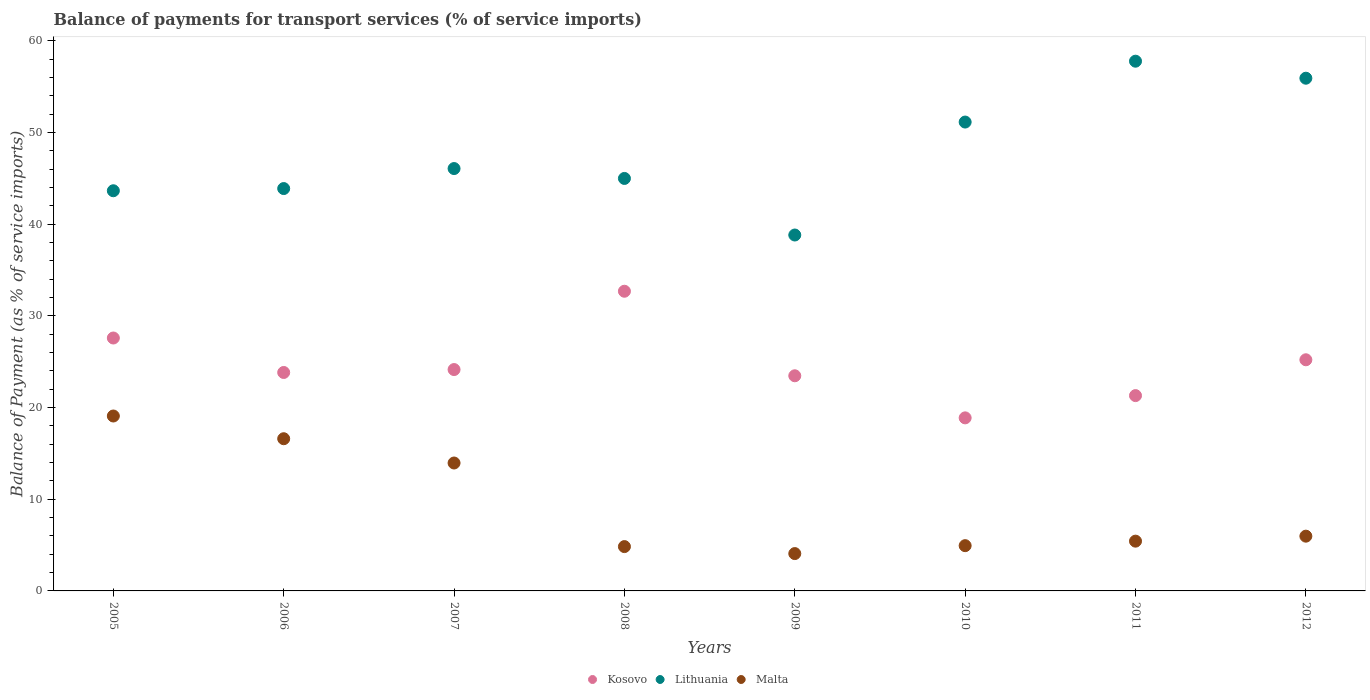What is the balance of payments for transport services in Lithuania in 2011?
Your answer should be compact. 57.79. Across all years, what is the maximum balance of payments for transport services in Kosovo?
Your answer should be very brief. 32.7. Across all years, what is the minimum balance of payments for transport services in Malta?
Give a very brief answer. 4.07. What is the total balance of payments for transport services in Lithuania in the graph?
Offer a very short reply. 382.36. What is the difference between the balance of payments for transport services in Malta in 2005 and that in 2006?
Give a very brief answer. 2.48. What is the difference between the balance of payments for transport services in Malta in 2009 and the balance of payments for transport services in Kosovo in 2007?
Keep it short and to the point. -20.08. What is the average balance of payments for transport services in Kosovo per year?
Your answer should be compact. 24.64. In the year 2010, what is the difference between the balance of payments for transport services in Malta and balance of payments for transport services in Kosovo?
Ensure brevity in your answer.  -13.94. What is the ratio of the balance of payments for transport services in Malta in 2006 to that in 2007?
Make the answer very short. 1.19. What is the difference between the highest and the second highest balance of payments for transport services in Kosovo?
Give a very brief answer. 5.1. What is the difference between the highest and the lowest balance of payments for transport services in Malta?
Offer a very short reply. 15.01. In how many years, is the balance of payments for transport services in Lithuania greater than the average balance of payments for transport services in Lithuania taken over all years?
Provide a succinct answer. 3. Is the sum of the balance of payments for transport services in Lithuania in 2006 and 2012 greater than the maximum balance of payments for transport services in Kosovo across all years?
Provide a succinct answer. Yes. Is the balance of payments for transport services in Lithuania strictly greater than the balance of payments for transport services in Malta over the years?
Give a very brief answer. Yes. What is the difference between two consecutive major ticks on the Y-axis?
Give a very brief answer. 10. Does the graph contain any zero values?
Make the answer very short. No. Does the graph contain grids?
Offer a very short reply. No. How many legend labels are there?
Your answer should be compact. 3. What is the title of the graph?
Offer a terse response. Balance of payments for transport services (% of service imports). What is the label or title of the X-axis?
Your response must be concise. Years. What is the label or title of the Y-axis?
Your answer should be compact. Balance of Payment (as % of service imports). What is the Balance of Payment (as % of service imports) of Kosovo in 2005?
Your answer should be compact. 27.59. What is the Balance of Payment (as % of service imports) in Lithuania in 2005?
Provide a short and direct response. 43.66. What is the Balance of Payment (as % of service imports) in Malta in 2005?
Offer a terse response. 19.08. What is the Balance of Payment (as % of service imports) in Kosovo in 2006?
Make the answer very short. 23.83. What is the Balance of Payment (as % of service imports) in Lithuania in 2006?
Provide a succinct answer. 43.9. What is the Balance of Payment (as % of service imports) of Malta in 2006?
Provide a succinct answer. 16.61. What is the Balance of Payment (as % of service imports) in Kosovo in 2007?
Your answer should be compact. 24.15. What is the Balance of Payment (as % of service imports) of Lithuania in 2007?
Your answer should be compact. 46.08. What is the Balance of Payment (as % of service imports) in Malta in 2007?
Ensure brevity in your answer.  13.96. What is the Balance of Payment (as % of service imports) in Kosovo in 2008?
Your answer should be compact. 32.7. What is the Balance of Payment (as % of service imports) of Lithuania in 2008?
Provide a succinct answer. 45. What is the Balance of Payment (as % of service imports) in Malta in 2008?
Give a very brief answer. 4.84. What is the Balance of Payment (as % of service imports) in Kosovo in 2009?
Make the answer very short. 23.47. What is the Balance of Payment (as % of service imports) in Lithuania in 2009?
Keep it short and to the point. 38.83. What is the Balance of Payment (as % of service imports) of Malta in 2009?
Offer a terse response. 4.07. What is the Balance of Payment (as % of service imports) of Kosovo in 2010?
Ensure brevity in your answer.  18.88. What is the Balance of Payment (as % of service imports) of Lithuania in 2010?
Your answer should be very brief. 51.15. What is the Balance of Payment (as % of service imports) of Malta in 2010?
Make the answer very short. 4.94. What is the Balance of Payment (as % of service imports) in Kosovo in 2011?
Provide a succinct answer. 21.31. What is the Balance of Payment (as % of service imports) of Lithuania in 2011?
Give a very brief answer. 57.79. What is the Balance of Payment (as % of service imports) in Malta in 2011?
Your answer should be compact. 5.43. What is the Balance of Payment (as % of service imports) of Kosovo in 2012?
Your answer should be very brief. 25.22. What is the Balance of Payment (as % of service imports) in Lithuania in 2012?
Your answer should be very brief. 55.94. What is the Balance of Payment (as % of service imports) in Malta in 2012?
Make the answer very short. 5.97. Across all years, what is the maximum Balance of Payment (as % of service imports) of Kosovo?
Provide a short and direct response. 32.7. Across all years, what is the maximum Balance of Payment (as % of service imports) in Lithuania?
Provide a short and direct response. 57.79. Across all years, what is the maximum Balance of Payment (as % of service imports) in Malta?
Provide a short and direct response. 19.08. Across all years, what is the minimum Balance of Payment (as % of service imports) of Kosovo?
Your answer should be very brief. 18.88. Across all years, what is the minimum Balance of Payment (as % of service imports) in Lithuania?
Provide a succinct answer. 38.83. Across all years, what is the minimum Balance of Payment (as % of service imports) in Malta?
Provide a short and direct response. 4.07. What is the total Balance of Payment (as % of service imports) of Kosovo in the graph?
Your answer should be compact. 197.16. What is the total Balance of Payment (as % of service imports) in Lithuania in the graph?
Provide a short and direct response. 382.36. What is the total Balance of Payment (as % of service imports) of Malta in the graph?
Make the answer very short. 74.9. What is the difference between the Balance of Payment (as % of service imports) in Kosovo in 2005 and that in 2006?
Offer a terse response. 3.76. What is the difference between the Balance of Payment (as % of service imports) in Lithuania in 2005 and that in 2006?
Your answer should be compact. -0.24. What is the difference between the Balance of Payment (as % of service imports) of Malta in 2005 and that in 2006?
Give a very brief answer. 2.48. What is the difference between the Balance of Payment (as % of service imports) in Kosovo in 2005 and that in 2007?
Your answer should be compact. 3.44. What is the difference between the Balance of Payment (as % of service imports) in Lithuania in 2005 and that in 2007?
Keep it short and to the point. -2.42. What is the difference between the Balance of Payment (as % of service imports) in Malta in 2005 and that in 2007?
Keep it short and to the point. 5.13. What is the difference between the Balance of Payment (as % of service imports) of Kosovo in 2005 and that in 2008?
Offer a very short reply. -5.1. What is the difference between the Balance of Payment (as % of service imports) of Lithuania in 2005 and that in 2008?
Ensure brevity in your answer.  -1.34. What is the difference between the Balance of Payment (as % of service imports) of Malta in 2005 and that in 2008?
Keep it short and to the point. 14.25. What is the difference between the Balance of Payment (as % of service imports) in Kosovo in 2005 and that in 2009?
Offer a terse response. 4.12. What is the difference between the Balance of Payment (as % of service imports) in Lithuania in 2005 and that in 2009?
Your response must be concise. 4.83. What is the difference between the Balance of Payment (as % of service imports) of Malta in 2005 and that in 2009?
Give a very brief answer. 15.01. What is the difference between the Balance of Payment (as % of service imports) of Kosovo in 2005 and that in 2010?
Give a very brief answer. 8.71. What is the difference between the Balance of Payment (as % of service imports) of Lithuania in 2005 and that in 2010?
Your response must be concise. -7.49. What is the difference between the Balance of Payment (as % of service imports) in Malta in 2005 and that in 2010?
Ensure brevity in your answer.  14.15. What is the difference between the Balance of Payment (as % of service imports) of Kosovo in 2005 and that in 2011?
Make the answer very short. 6.28. What is the difference between the Balance of Payment (as % of service imports) of Lithuania in 2005 and that in 2011?
Give a very brief answer. -14.14. What is the difference between the Balance of Payment (as % of service imports) of Malta in 2005 and that in 2011?
Make the answer very short. 13.65. What is the difference between the Balance of Payment (as % of service imports) in Kosovo in 2005 and that in 2012?
Provide a short and direct response. 2.38. What is the difference between the Balance of Payment (as % of service imports) of Lithuania in 2005 and that in 2012?
Keep it short and to the point. -12.28. What is the difference between the Balance of Payment (as % of service imports) of Malta in 2005 and that in 2012?
Keep it short and to the point. 13.11. What is the difference between the Balance of Payment (as % of service imports) of Kosovo in 2006 and that in 2007?
Offer a very short reply. -0.32. What is the difference between the Balance of Payment (as % of service imports) of Lithuania in 2006 and that in 2007?
Offer a terse response. -2.18. What is the difference between the Balance of Payment (as % of service imports) of Malta in 2006 and that in 2007?
Provide a succinct answer. 2.65. What is the difference between the Balance of Payment (as % of service imports) of Kosovo in 2006 and that in 2008?
Provide a succinct answer. -8.86. What is the difference between the Balance of Payment (as % of service imports) in Lithuania in 2006 and that in 2008?
Give a very brief answer. -1.1. What is the difference between the Balance of Payment (as % of service imports) in Malta in 2006 and that in 2008?
Your answer should be compact. 11.77. What is the difference between the Balance of Payment (as % of service imports) in Kosovo in 2006 and that in 2009?
Ensure brevity in your answer.  0.36. What is the difference between the Balance of Payment (as % of service imports) in Lithuania in 2006 and that in 2009?
Give a very brief answer. 5.07. What is the difference between the Balance of Payment (as % of service imports) in Malta in 2006 and that in 2009?
Ensure brevity in your answer.  12.53. What is the difference between the Balance of Payment (as % of service imports) of Kosovo in 2006 and that in 2010?
Give a very brief answer. 4.95. What is the difference between the Balance of Payment (as % of service imports) in Lithuania in 2006 and that in 2010?
Offer a terse response. -7.26. What is the difference between the Balance of Payment (as % of service imports) of Malta in 2006 and that in 2010?
Give a very brief answer. 11.67. What is the difference between the Balance of Payment (as % of service imports) of Kosovo in 2006 and that in 2011?
Your answer should be very brief. 2.52. What is the difference between the Balance of Payment (as % of service imports) in Lithuania in 2006 and that in 2011?
Provide a succinct answer. -13.9. What is the difference between the Balance of Payment (as % of service imports) of Malta in 2006 and that in 2011?
Offer a terse response. 11.18. What is the difference between the Balance of Payment (as % of service imports) of Kosovo in 2006 and that in 2012?
Offer a very short reply. -1.39. What is the difference between the Balance of Payment (as % of service imports) in Lithuania in 2006 and that in 2012?
Provide a short and direct response. -12.04. What is the difference between the Balance of Payment (as % of service imports) in Malta in 2006 and that in 2012?
Ensure brevity in your answer.  10.63. What is the difference between the Balance of Payment (as % of service imports) of Kosovo in 2007 and that in 2008?
Your response must be concise. -8.54. What is the difference between the Balance of Payment (as % of service imports) in Lithuania in 2007 and that in 2008?
Provide a short and direct response. 1.08. What is the difference between the Balance of Payment (as % of service imports) in Malta in 2007 and that in 2008?
Ensure brevity in your answer.  9.12. What is the difference between the Balance of Payment (as % of service imports) in Kosovo in 2007 and that in 2009?
Ensure brevity in your answer.  0.68. What is the difference between the Balance of Payment (as % of service imports) in Lithuania in 2007 and that in 2009?
Offer a terse response. 7.25. What is the difference between the Balance of Payment (as % of service imports) of Malta in 2007 and that in 2009?
Keep it short and to the point. 9.88. What is the difference between the Balance of Payment (as % of service imports) of Kosovo in 2007 and that in 2010?
Your response must be concise. 5.27. What is the difference between the Balance of Payment (as % of service imports) in Lithuania in 2007 and that in 2010?
Offer a very short reply. -5.07. What is the difference between the Balance of Payment (as % of service imports) in Malta in 2007 and that in 2010?
Provide a succinct answer. 9.02. What is the difference between the Balance of Payment (as % of service imports) of Kosovo in 2007 and that in 2011?
Provide a short and direct response. 2.84. What is the difference between the Balance of Payment (as % of service imports) of Lithuania in 2007 and that in 2011?
Offer a terse response. -11.71. What is the difference between the Balance of Payment (as % of service imports) in Malta in 2007 and that in 2011?
Your answer should be compact. 8.53. What is the difference between the Balance of Payment (as % of service imports) in Kosovo in 2007 and that in 2012?
Make the answer very short. -1.07. What is the difference between the Balance of Payment (as % of service imports) of Lithuania in 2007 and that in 2012?
Your answer should be very brief. -9.86. What is the difference between the Balance of Payment (as % of service imports) in Malta in 2007 and that in 2012?
Ensure brevity in your answer.  7.98. What is the difference between the Balance of Payment (as % of service imports) in Kosovo in 2008 and that in 2009?
Provide a succinct answer. 9.22. What is the difference between the Balance of Payment (as % of service imports) in Lithuania in 2008 and that in 2009?
Keep it short and to the point. 6.17. What is the difference between the Balance of Payment (as % of service imports) in Malta in 2008 and that in 2009?
Offer a very short reply. 0.76. What is the difference between the Balance of Payment (as % of service imports) in Kosovo in 2008 and that in 2010?
Give a very brief answer. 13.82. What is the difference between the Balance of Payment (as % of service imports) in Lithuania in 2008 and that in 2010?
Ensure brevity in your answer.  -6.15. What is the difference between the Balance of Payment (as % of service imports) in Malta in 2008 and that in 2010?
Keep it short and to the point. -0.1. What is the difference between the Balance of Payment (as % of service imports) of Kosovo in 2008 and that in 2011?
Your answer should be compact. 11.39. What is the difference between the Balance of Payment (as % of service imports) in Lithuania in 2008 and that in 2011?
Give a very brief answer. -12.79. What is the difference between the Balance of Payment (as % of service imports) in Malta in 2008 and that in 2011?
Your answer should be very brief. -0.59. What is the difference between the Balance of Payment (as % of service imports) of Kosovo in 2008 and that in 2012?
Keep it short and to the point. 7.48. What is the difference between the Balance of Payment (as % of service imports) of Lithuania in 2008 and that in 2012?
Make the answer very short. -10.94. What is the difference between the Balance of Payment (as % of service imports) in Malta in 2008 and that in 2012?
Ensure brevity in your answer.  -1.14. What is the difference between the Balance of Payment (as % of service imports) in Kosovo in 2009 and that in 2010?
Keep it short and to the point. 4.59. What is the difference between the Balance of Payment (as % of service imports) in Lithuania in 2009 and that in 2010?
Provide a short and direct response. -12.32. What is the difference between the Balance of Payment (as % of service imports) of Malta in 2009 and that in 2010?
Provide a succinct answer. -0.86. What is the difference between the Balance of Payment (as % of service imports) in Kosovo in 2009 and that in 2011?
Your answer should be very brief. 2.16. What is the difference between the Balance of Payment (as % of service imports) in Lithuania in 2009 and that in 2011?
Your answer should be very brief. -18.96. What is the difference between the Balance of Payment (as % of service imports) in Malta in 2009 and that in 2011?
Give a very brief answer. -1.36. What is the difference between the Balance of Payment (as % of service imports) of Kosovo in 2009 and that in 2012?
Provide a succinct answer. -1.75. What is the difference between the Balance of Payment (as % of service imports) in Lithuania in 2009 and that in 2012?
Ensure brevity in your answer.  -17.11. What is the difference between the Balance of Payment (as % of service imports) in Malta in 2009 and that in 2012?
Give a very brief answer. -1.9. What is the difference between the Balance of Payment (as % of service imports) in Kosovo in 2010 and that in 2011?
Offer a terse response. -2.43. What is the difference between the Balance of Payment (as % of service imports) in Lithuania in 2010 and that in 2011?
Make the answer very short. -6.64. What is the difference between the Balance of Payment (as % of service imports) in Malta in 2010 and that in 2011?
Provide a short and direct response. -0.49. What is the difference between the Balance of Payment (as % of service imports) of Kosovo in 2010 and that in 2012?
Offer a terse response. -6.34. What is the difference between the Balance of Payment (as % of service imports) in Lithuania in 2010 and that in 2012?
Keep it short and to the point. -4.78. What is the difference between the Balance of Payment (as % of service imports) of Malta in 2010 and that in 2012?
Offer a very short reply. -1.04. What is the difference between the Balance of Payment (as % of service imports) of Kosovo in 2011 and that in 2012?
Your answer should be very brief. -3.91. What is the difference between the Balance of Payment (as % of service imports) in Lithuania in 2011 and that in 2012?
Provide a succinct answer. 1.86. What is the difference between the Balance of Payment (as % of service imports) of Malta in 2011 and that in 2012?
Make the answer very short. -0.54. What is the difference between the Balance of Payment (as % of service imports) of Kosovo in 2005 and the Balance of Payment (as % of service imports) of Lithuania in 2006?
Offer a terse response. -16.3. What is the difference between the Balance of Payment (as % of service imports) in Kosovo in 2005 and the Balance of Payment (as % of service imports) in Malta in 2006?
Offer a terse response. 10.99. What is the difference between the Balance of Payment (as % of service imports) in Lithuania in 2005 and the Balance of Payment (as % of service imports) in Malta in 2006?
Your answer should be compact. 27.05. What is the difference between the Balance of Payment (as % of service imports) in Kosovo in 2005 and the Balance of Payment (as % of service imports) in Lithuania in 2007?
Provide a short and direct response. -18.49. What is the difference between the Balance of Payment (as % of service imports) in Kosovo in 2005 and the Balance of Payment (as % of service imports) in Malta in 2007?
Provide a succinct answer. 13.64. What is the difference between the Balance of Payment (as % of service imports) of Lithuania in 2005 and the Balance of Payment (as % of service imports) of Malta in 2007?
Your answer should be very brief. 29.7. What is the difference between the Balance of Payment (as % of service imports) of Kosovo in 2005 and the Balance of Payment (as % of service imports) of Lithuania in 2008?
Keep it short and to the point. -17.41. What is the difference between the Balance of Payment (as % of service imports) in Kosovo in 2005 and the Balance of Payment (as % of service imports) in Malta in 2008?
Offer a terse response. 22.76. What is the difference between the Balance of Payment (as % of service imports) of Lithuania in 2005 and the Balance of Payment (as % of service imports) of Malta in 2008?
Keep it short and to the point. 38.82. What is the difference between the Balance of Payment (as % of service imports) of Kosovo in 2005 and the Balance of Payment (as % of service imports) of Lithuania in 2009?
Make the answer very short. -11.24. What is the difference between the Balance of Payment (as % of service imports) of Kosovo in 2005 and the Balance of Payment (as % of service imports) of Malta in 2009?
Your response must be concise. 23.52. What is the difference between the Balance of Payment (as % of service imports) of Lithuania in 2005 and the Balance of Payment (as % of service imports) of Malta in 2009?
Give a very brief answer. 39.59. What is the difference between the Balance of Payment (as % of service imports) of Kosovo in 2005 and the Balance of Payment (as % of service imports) of Lithuania in 2010?
Keep it short and to the point. -23.56. What is the difference between the Balance of Payment (as % of service imports) in Kosovo in 2005 and the Balance of Payment (as % of service imports) in Malta in 2010?
Make the answer very short. 22.66. What is the difference between the Balance of Payment (as % of service imports) of Lithuania in 2005 and the Balance of Payment (as % of service imports) of Malta in 2010?
Ensure brevity in your answer.  38.72. What is the difference between the Balance of Payment (as % of service imports) of Kosovo in 2005 and the Balance of Payment (as % of service imports) of Lithuania in 2011?
Provide a succinct answer. -30.2. What is the difference between the Balance of Payment (as % of service imports) of Kosovo in 2005 and the Balance of Payment (as % of service imports) of Malta in 2011?
Offer a very short reply. 22.16. What is the difference between the Balance of Payment (as % of service imports) of Lithuania in 2005 and the Balance of Payment (as % of service imports) of Malta in 2011?
Offer a very short reply. 38.23. What is the difference between the Balance of Payment (as % of service imports) in Kosovo in 2005 and the Balance of Payment (as % of service imports) in Lithuania in 2012?
Your answer should be compact. -28.34. What is the difference between the Balance of Payment (as % of service imports) of Kosovo in 2005 and the Balance of Payment (as % of service imports) of Malta in 2012?
Offer a very short reply. 21.62. What is the difference between the Balance of Payment (as % of service imports) in Lithuania in 2005 and the Balance of Payment (as % of service imports) in Malta in 2012?
Provide a succinct answer. 37.69. What is the difference between the Balance of Payment (as % of service imports) of Kosovo in 2006 and the Balance of Payment (as % of service imports) of Lithuania in 2007?
Your answer should be compact. -22.25. What is the difference between the Balance of Payment (as % of service imports) of Kosovo in 2006 and the Balance of Payment (as % of service imports) of Malta in 2007?
Your response must be concise. 9.88. What is the difference between the Balance of Payment (as % of service imports) in Lithuania in 2006 and the Balance of Payment (as % of service imports) in Malta in 2007?
Your answer should be very brief. 29.94. What is the difference between the Balance of Payment (as % of service imports) of Kosovo in 2006 and the Balance of Payment (as % of service imports) of Lithuania in 2008?
Offer a very short reply. -21.17. What is the difference between the Balance of Payment (as % of service imports) of Kosovo in 2006 and the Balance of Payment (as % of service imports) of Malta in 2008?
Offer a very short reply. 19. What is the difference between the Balance of Payment (as % of service imports) in Lithuania in 2006 and the Balance of Payment (as % of service imports) in Malta in 2008?
Offer a very short reply. 39.06. What is the difference between the Balance of Payment (as % of service imports) in Kosovo in 2006 and the Balance of Payment (as % of service imports) in Lithuania in 2009?
Your answer should be compact. -15. What is the difference between the Balance of Payment (as % of service imports) in Kosovo in 2006 and the Balance of Payment (as % of service imports) in Malta in 2009?
Ensure brevity in your answer.  19.76. What is the difference between the Balance of Payment (as % of service imports) of Lithuania in 2006 and the Balance of Payment (as % of service imports) of Malta in 2009?
Offer a terse response. 39.82. What is the difference between the Balance of Payment (as % of service imports) of Kosovo in 2006 and the Balance of Payment (as % of service imports) of Lithuania in 2010?
Your response must be concise. -27.32. What is the difference between the Balance of Payment (as % of service imports) in Kosovo in 2006 and the Balance of Payment (as % of service imports) in Malta in 2010?
Provide a succinct answer. 18.9. What is the difference between the Balance of Payment (as % of service imports) of Lithuania in 2006 and the Balance of Payment (as % of service imports) of Malta in 2010?
Offer a very short reply. 38.96. What is the difference between the Balance of Payment (as % of service imports) in Kosovo in 2006 and the Balance of Payment (as % of service imports) in Lithuania in 2011?
Ensure brevity in your answer.  -33.96. What is the difference between the Balance of Payment (as % of service imports) in Kosovo in 2006 and the Balance of Payment (as % of service imports) in Malta in 2011?
Offer a very short reply. 18.4. What is the difference between the Balance of Payment (as % of service imports) in Lithuania in 2006 and the Balance of Payment (as % of service imports) in Malta in 2011?
Offer a terse response. 38.47. What is the difference between the Balance of Payment (as % of service imports) of Kosovo in 2006 and the Balance of Payment (as % of service imports) of Lithuania in 2012?
Make the answer very short. -32.11. What is the difference between the Balance of Payment (as % of service imports) of Kosovo in 2006 and the Balance of Payment (as % of service imports) of Malta in 2012?
Provide a short and direct response. 17.86. What is the difference between the Balance of Payment (as % of service imports) in Lithuania in 2006 and the Balance of Payment (as % of service imports) in Malta in 2012?
Offer a very short reply. 37.92. What is the difference between the Balance of Payment (as % of service imports) of Kosovo in 2007 and the Balance of Payment (as % of service imports) of Lithuania in 2008?
Offer a very short reply. -20.85. What is the difference between the Balance of Payment (as % of service imports) of Kosovo in 2007 and the Balance of Payment (as % of service imports) of Malta in 2008?
Offer a terse response. 19.32. What is the difference between the Balance of Payment (as % of service imports) of Lithuania in 2007 and the Balance of Payment (as % of service imports) of Malta in 2008?
Give a very brief answer. 41.25. What is the difference between the Balance of Payment (as % of service imports) of Kosovo in 2007 and the Balance of Payment (as % of service imports) of Lithuania in 2009?
Your answer should be compact. -14.68. What is the difference between the Balance of Payment (as % of service imports) of Kosovo in 2007 and the Balance of Payment (as % of service imports) of Malta in 2009?
Keep it short and to the point. 20.08. What is the difference between the Balance of Payment (as % of service imports) of Lithuania in 2007 and the Balance of Payment (as % of service imports) of Malta in 2009?
Provide a short and direct response. 42.01. What is the difference between the Balance of Payment (as % of service imports) of Kosovo in 2007 and the Balance of Payment (as % of service imports) of Lithuania in 2010?
Ensure brevity in your answer.  -27. What is the difference between the Balance of Payment (as % of service imports) in Kosovo in 2007 and the Balance of Payment (as % of service imports) in Malta in 2010?
Offer a very short reply. 19.21. What is the difference between the Balance of Payment (as % of service imports) of Lithuania in 2007 and the Balance of Payment (as % of service imports) of Malta in 2010?
Ensure brevity in your answer.  41.14. What is the difference between the Balance of Payment (as % of service imports) in Kosovo in 2007 and the Balance of Payment (as % of service imports) in Lithuania in 2011?
Your answer should be compact. -33.64. What is the difference between the Balance of Payment (as % of service imports) in Kosovo in 2007 and the Balance of Payment (as % of service imports) in Malta in 2011?
Offer a terse response. 18.72. What is the difference between the Balance of Payment (as % of service imports) in Lithuania in 2007 and the Balance of Payment (as % of service imports) in Malta in 2011?
Your response must be concise. 40.65. What is the difference between the Balance of Payment (as % of service imports) in Kosovo in 2007 and the Balance of Payment (as % of service imports) in Lithuania in 2012?
Your response must be concise. -31.79. What is the difference between the Balance of Payment (as % of service imports) in Kosovo in 2007 and the Balance of Payment (as % of service imports) in Malta in 2012?
Your response must be concise. 18.18. What is the difference between the Balance of Payment (as % of service imports) of Lithuania in 2007 and the Balance of Payment (as % of service imports) of Malta in 2012?
Offer a terse response. 40.11. What is the difference between the Balance of Payment (as % of service imports) in Kosovo in 2008 and the Balance of Payment (as % of service imports) in Lithuania in 2009?
Offer a terse response. -6.13. What is the difference between the Balance of Payment (as % of service imports) of Kosovo in 2008 and the Balance of Payment (as % of service imports) of Malta in 2009?
Ensure brevity in your answer.  28.62. What is the difference between the Balance of Payment (as % of service imports) in Lithuania in 2008 and the Balance of Payment (as % of service imports) in Malta in 2009?
Your response must be concise. 40.93. What is the difference between the Balance of Payment (as % of service imports) in Kosovo in 2008 and the Balance of Payment (as % of service imports) in Lithuania in 2010?
Provide a succinct answer. -18.46. What is the difference between the Balance of Payment (as % of service imports) of Kosovo in 2008 and the Balance of Payment (as % of service imports) of Malta in 2010?
Your answer should be very brief. 27.76. What is the difference between the Balance of Payment (as % of service imports) in Lithuania in 2008 and the Balance of Payment (as % of service imports) in Malta in 2010?
Offer a very short reply. 40.06. What is the difference between the Balance of Payment (as % of service imports) of Kosovo in 2008 and the Balance of Payment (as % of service imports) of Lithuania in 2011?
Make the answer very short. -25.1. What is the difference between the Balance of Payment (as % of service imports) of Kosovo in 2008 and the Balance of Payment (as % of service imports) of Malta in 2011?
Provide a succinct answer. 27.27. What is the difference between the Balance of Payment (as % of service imports) of Lithuania in 2008 and the Balance of Payment (as % of service imports) of Malta in 2011?
Your response must be concise. 39.57. What is the difference between the Balance of Payment (as % of service imports) in Kosovo in 2008 and the Balance of Payment (as % of service imports) in Lithuania in 2012?
Ensure brevity in your answer.  -23.24. What is the difference between the Balance of Payment (as % of service imports) in Kosovo in 2008 and the Balance of Payment (as % of service imports) in Malta in 2012?
Your response must be concise. 26.72. What is the difference between the Balance of Payment (as % of service imports) of Lithuania in 2008 and the Balance of Payment (as % of service imports) of Malta in 2012?
Give a very brief answer. 39.03. What is the difference between the Balance of Payment (as % of service imports) of Kosovo in 2009 and the Balance of Payment (as % of service imports) of Lithuania in 2010?
Offer a terse response. -27.68. What is the difference between the Balance of Payment (as % of service imports) of Kosovo in 2009 and the Balance of Payment (as % of service imports) of Malta in 2010?
Your response must be concise. 18.53. What is the difference between the Balance of Payment (as % of service imports) in Lithuania in 2009 and the Balance of Payment (as % of service imports) in Malta in 2010?
Ensure brevity in your answer.  33.89. What is the difference between the Balance of Payment (as % of service imports) of Kosovo in 2009 and the Balance of Payment (as % of service imports) of Lithuania in 2011?
Offer a very short reply. -34.32. What is the difference between the Balance of Payment (as % of service imports) of Kosovo in 2009 and the Balance of Payment (as % of service imports) of Malta in 2011?
Offer a very short reply. 18.04. What is the difference between the Balance of Payment (as % of service imports) of Lithuania in 2009 and the Balance of Payment (as % of service imports) of Malta in 2011?
Provide a short and direct response. 33.4. What is the difference between the Balance of Payment (as % of service imports) of Kosovo in 2009 and the Balance of Payment (as % of service imports) of Lithuania in 2012?
Give a very brief answer. -32.47. What is the difference between the Balance of Payment (as % of service imports) in Kosovo in 2009 and the Balance of Payment (as % of service imports) in Malta in 2012?
Your answer should be compact. 17.5. What is the difference between the Balance of Payment (as % of service imports) in Lithuania in 2009 and the Balance of Payment (as % of service imports) in Malta in 2012?
Your answer should be very brief. 32.86. What is the difference between the Balance of Payment (as % of service imports) of Kosovo in 2010 and the Balance of Payment (as % of service imports) of Lithuania in 2011?
Offer a very short reply. -38.91. What is the difference between the Balance of Payment (as % of service imports) in Kosovo in 2010 and the Balance of Payment (as % of service imports) in Malta in 2011?
Provide a succinct answer. 13.45. What is the difference between the Balance of Payment (as % of service imports) of Lithuania in 2010 and the Balance of Payment (as % of service imports) of Malta in 2011?
Offer a very short reply. 45.72. What is the difference between the Balance of Payment (as % of service imports) of Kosovo in 2010 and the Balance of Payment (as % of service imports) of Lithuania in 2012?
Offer a terse response. -37.06. What is the difference between the Balance of Payment (as % of service imports) of Kosovo in 2010 and the Balance of Payment (as % of service imports) of Malta in 2012?
Your answer should be very brief. 12.91. What is the difference between the Balance of Payment (as % of service imports) in Lithuania in 2010 and the Balance of Payment (as % of service imports) in Malta in 2012?
Keep it short and to the point. 45.18. What is the difference between the Balance of Payment (as % of service imports) of Kosovo in 2011 and the Balance of Payment (as % of service imports) of Lithuania in 2012?
Your answer should be very brief. -34.63. What is the difference between the Balance of Payment (as % of service imports) of Kosovo in 2011 and the Balance of Payment (as % of service imports) of Malta in 2012?
Keep it short and to the point. 15.34. What is the difference between the Balance of Payment (as % of service imports) of Lithuania in 2011 and the Balance of Payment (as % of service imports) of Malta in 2012?
Your response must be concise. 51.82. What is the average Balance of Payment (as % of service imports) in Kosovo per year?
Provide a short and direct response. 24.64. What is the average Balance of Payment (as % of service imports) of Lithuania per year?
Your answer should be very brief. 47.79. What is the average Balance of Payment (as % of service imports) in Malta per year?
Your response must be concise. 9.36. In the year 2005, what is the difference between the Balance of Payment (as % of service imports) in Kosovo and Balance of Payment (as % of service imports) in Lithuania?
Offer a very short reply. -16.07. In the year 2005, what is the difference between the Balance of Payment (as % of service imports) in Kosovo and Balance of Payment (as % of service imports) in Malta?
Your answer should be compact. 8.51. In the year 2005, what is the difference between the Balance of Payment (as % of service imports) in Lithuania and Balance of Payment (as % of service imports) in Malta?
Your answer should be very brief. 24.58. In the year 2006, what is the difference between the Balance of Payment (as % of service imports) of Kosovo and Balance of Payment (as % of service imports) of Lithuania?
Keep it short and to the point. -20.07. In the year 2006, what is the difference between the Balance of Payment (as % of service imports) in Kosovo and Balance of Payment (as % of service imports) in Malta?
Your response must be concise. 7.23. In the year 2006, what is the difference between the Balance of Payment (as % of service imports) of Lithuania and Balance of Payment (as % of service imports) of Malta?
Give a very brief answer. 27.29. In the year 2007, what is the difference between the Balance of Payment (as % of service imports) in Kosovo and Balance of Payment (as % of service imports) in Lithuania?
Give a very brief answer. -21.93. In the year 2007, what is the difference between the Balance of Payment (as % of service imports) in Kosovo and Balance of Payment (as % of service imports) in Malta?
Offer a very short reply. 10.2. In the year 2007, what is the difference between the Balance of Payment (as % of service imports) of Lithuania and Balance of Payment (as % of service imports) of Malta?
Offer a very short reply. 32.13. In the year 2008, what is the difference between the Balance of Payment (as % of service imports) in Kosovo and Balance of Payment (as % of service imports) in Lithuania?
Provide a short and direct response. -12.31. In the year 2008, what is the difference between the Balance of Payment (as % of service imports) of Kosovo and Balance of Payment (as % of service imports) of Malta?
Provide a succinct answer. 27.86. In the year 2008, what is the difference between the Balance of Payment (as % of service imports) of Lithuania and Balance of Payment (as % of service imports) of Malta?
Offer a terse response. 40.17. In the year 2009, what is the difference between the Balance of Payment (as % of service imports) of Kosovo and Balance of Payment (as % of service imports) of Lithuania?
Offer a terse response. -15.36. In the year 2009, what is the difference between the Balance of Payment (as % of service imports) in Kosovo and Balance of Payment (as % of service imports) in Malta?
Make the answer very short. 19.4. In the year 2009, what is the difference between the Balance of Payment (as % of service imports) in Lithuania and Balance of Payment (as % of service imports) in Malta?
Give a very brief answer. 34.76. In the year 2010, what is the difference between the Balance of Payment (as % of service imports) of Kosovo and Balance of Payment (as % of service imports) of Lithuania?
Offer a very short reply. -32.27. In the year 2010, what is the difference between the Balance of Payment (as % of service imports) in Kosovo and Balance of Payment (as % of service imports) in Malta?
Your answer should be very brief. 13.94. In the year 2010, what is the difference between the Balance of Payment (as % of service imports) of Lithuania and Balance of Payment (as % of service imports) of Malta?
Offer a terse response. 46.22. In the year 2011, what is the difference between the Balance of Payment (as % of service imports) of Kosovo and Balance of Payment (as % of service imports) of Lithuania?
Give a very brief answer. -36.49. In the year 2011, what is the difference between the Balance of Payment (as % of service imports) of Kosovo and Balance of Payment (as % of service imports) of Malta?
Your response must be concise. 15.88. In the year 2011, what is the difference between the Balance of Payment (as % of service imports) of Lithuania and Balance of Payment (as % of service imports) of Malta?
Offer a terse response. 52.36. In the year 2012, what is the difference between the Balance of Payment (as % of service imports) in Kosovo and Balance of Payment (as % of service imports) in Lithuania?
Keep it short and to the point. -30.72. In the year 2012, what is the difference between the Balance of Payment (as % of service imports) of Kosovo and Balance of Payment (as % of service imports) of Malta?
Your answer should be very brief. 19.24. In the year 2012, what is the difference between the Balance of Payment (as % of service imports) in Lithuania and Balance of Payment (as % of service imports) in Malta?
Your answer should be very brief. 49.96. What is the ratio of the Balance of Payment (as % of service imports) in Kosovo in 2005 to that in 2006?
Give a very brief answer. 1.16. What is the ratio of the Balance of Payment (as % of service imports) of Lithuania in 2005 to that in 2006?
Ensure brevity in your answer.  0.99. What is the ratio of the Balance of Payment (as % of service imports) of Malta in 2005 to that in 2006?
Keep it short and to the point. 1.15. What is the ratio of the Balance of Payment (as % of service imports) in Kosovo in 2005 to that in 2007?
Provide a short and direct response. 1.14. What is the ratio of the Balance of Payment (as % of service imports) in Lithuania in 2005 to that in 2007?
Your response must be concise. 0.95. What is the ratio of the Balance of Payment (as % of service imports) in Malta in 2005 to that in 2007?
Give a very brief answer. 1.37. What is the ratio of the Balance of Payment (as % of service imports) of Kosovo in 2005 to that in 2008?
Ensure brevity in your answer.  0.84. What is the ratio of the Balance of Payment (as % of service imports) in Lithuania in 2005 to that in 2008?
Your answer should be very brief. 0.97. What is the ratio of the Balance of Payment (as % of service imports) in Malta in 2005 to that in 2008?
Your answer should be compact. 3.95. What is the ratio of the Balance of Payment (as % of service imports) in Kosovo in 2005 to that in 2009?
Give a very brief answer. 1.18. What is the ratio of the Balance of Payment (as % of service imports) in Lithuania in 2005 to that in 2009?
Your answer should be compact. 1.12. What is the ratio of the Balance of Payment (as % of service imports) of Malta in 2005 to that in 2009?
Ensure brevity in your answer.  4.68. What is the ratio of the Balance of Payment (as % of service imports) in Kosovo in 2005 to that in 2010?
Keep it short and to the point. 1.46. What is the ratio of the Balance of Payment (as % of service imports) in Lithuania in 2005 to that in 2010?
Give a very brief answer. 0.85. What is the ratio of the Balance of Payment (as % of service imports) of Malta in 2005 to that in 2010?
Provide a short and direct response. 3.86. What is the ratio of the Balance of Payment (as % of service imports) of Kosovo in 2005 to that in 2011?
Make the answer very short. 1.29. What is the ratio of the Balance of Payment (as % of service imports) of Lithuania in 2005 to that in 2011?
Keep it short and to the point. 0.76. What is the ratio of the Balance of Payment (as % of service imports) in Malta in 2005 to that in 2011?
Your answer should be compact. 3.51. What is the ratio of the Balance of Payment (as % of service imports) of Kosovo in 2005 to that in 2012?
Keep it short and to the point. 1.09. What is the ratio of the Balance of Payment (as % of service imports) in Lithuania in 2005 to that in 2012?
Offer a very short reply. 0.78. What is the ratio of the Balance of Payment (as % of service imports) of Malta in 2005 to that in 2012?
Your answer should be compact. 3.19. What is the ratio of the Balance of Payment (as % of service imports) in Kosovo in 2006 to that in 2007?
Offer a very short reply. 0.99. What is the ratio of the Balance of Payment (as % of service imports) in Lithuania in 2006 to that in 2007?
Make the answer very short. 0.95. What is the ratio of the Balance of Payment (as % of service imports) of Malta in 2006 to that in 2007?
Provide a succinct answer. 1.19. What is the ratio of the Balance of Payment (as % of service imports) in Kosovo in 2006 to that in 2008?
Keep it short and to the point. 0.73. What is the ratio of the Balance of Payment (as % of service imports) of Lithuania in 2006 to that in 2008?
Keep it short and to the point. 0.98. What is the ratio of the Balance of Payment (as % of service imports) in Malta in 2006 to that in 2008?
Offer a terse response. 3.43. What is the ratio of the Balance of Payment (as % of service imports) of Kosovo in 2006 to that in 2009?
Your answer should be compact. 1.02. What is the ratio of the Balance of Payment (as % of service imports) in Lithuania in 2006 to that in 2009?
Offer a very short reply. 1.13. What is the ratio of the Balance of Payment (as % of service imports) of Malta in 2006 to that in 2009?
Offer a terse response. 4.08. What is the ratio of the Balance of Payment (as % of service imports) in Kosovo in 2006 to that in 2010?
Give a very brief answer. 1.26. What is the ratio of the Balance of Payment (as % of service imports) of Lithuania in 2006 to that in 2010?
Provide a succinct answer. 0.86. What is the ratio of the Balance of Payment (as % of service imports) in Malta in 2006 to that in 2010?
Provide a succinct answer. 3.36. What is the ratio of the Balance of Payment (as % of service imports) of Kosovo in 2006 to that in 2011?
Ensure brevity in your answer.  1.12. What is the ratio of the Balance of Payment (as % of service imports) in Lithuania in 2006 to that in 2011?
Make the answer very short. 0.76. What is the ratio of the Balance of Payment (as % of service imports) of Malta in 2006 to that in 2011?
Keep it short and to the point. 3.06. What is the ratio of the Balance of Payment (as % of service imports) in Kosovo in 2006 to that in 2012?
Ensure brevity in your answer.  0.95. What is the ratio of the Balance of Payment (as % of service imports) in Lithuania in 2006 to that in 2012?
Your response must be concise. 0.78. What is the ratio of the Balance of Payment (as % of service imports) of Malta in 2006 to that in 2012?
Keep it short and to the point. 2.78. What is the ratio of the Balance of Payment (as % of service imports) of Kosovo in 2007 to that in 2008?
Give a very brief answer. 0.74. What is the ratio of the Balance of Payment (as % of service imports) of Lithuania in 2007 to that in 2008?
Provide a succinct answer. 1.02. What is the ratio of the Balance of Payment (as % of service imports) of Malta in 2007 to that in 2008?
Offer a terse response. 2.89. What is the ratio of the Balance of Payment (as % of service imports) of Kosovo in 2007 to that in 2009?
Your response must be concise. 1.03. What is the ratio of the Balance of Payment (as % of service imports) of Lithuania in 2007 to that in 2009?
Make the answer very short. 1.19. What is the ratio of the Balance of Payment (as % of service imports) in Malta in 2007 to that in 2009?
Your response must be concise. 3.43. What is the ratio of the Balance of Payment (as % of service imports) of Kosovo in 2007 to that in 2010?
Your answer should be very brief. 1.28. What is the ratio of the Balance of Payment (as % of service imports) of Lithuania in 2007 to that in 2010?
Ensure brevity in your answer.  0.9. What is the ratio of the Balance of Payment (as % of service imports) in Malta in 2007 to that in 2010?
Your answer should be compact. 2.83. What is the ratio of the Balance of Payment (as % of service imports) of Kosovo in 2007 to that in 2011?
Your answer should be very brief. 1.13. What is the ratio of the Balance of Payment (as % of service imports) of Lithuania in 2007 to that in 2011?
Make the answer very short. 0.8. What is the ratio of the Balance of Payment (as % of service imports) of Malta in 2007 to that in 2011?
Provide a short and direct response. 2.57. What is the ratio of the Balance of Payment (as % of service imports) of Kosovo in 2007 to that in 2012?
Your answer should be very brief. 0.96. What is the ratio of the Balance of Payment (as % of service imports) in Lithuania in 2007 to that in 2012?
Ensure brevity in your answer.  0.82. What is the ratio of the Balance of Payment (as % of service imports) in Malta in 2007 to that in 2012?
Make the answer very short. 2.34. What is the ratio of the Balance of Payment (as % of service imports) of Kosovo in 2008 to that in 2009?
Make the answer very short. 1.39. What is the ratio of the Balance of Payment (as % of service imports) of Lithuania in 2008 to that in 2009?
Your answer should be very brief. 1.16. What is the ratio of the Balance of Payment (as % of service imports) of Malta in 2008 to that in 2009?
Keep it short and to the point. 1.19. What is the ratio of the Balance of Payment (as % of service imports) in Kosovo in 2008 to that in 2010?
Make the answer very short. 1.73. What is the ratio of the Balance of Payment (as % of service imports) of Lithuania in 2008 to that in 2010?
Your answer should be compact. 0.88. What is the ratio of the Balance of Payment (as % of service imports) in Malta in 2008 to that in 2010?
Give a very brief answer. 0.98. What is the ratio of the Balance of Payment (as % of service imports) in Kosovo in 2008 to that in 2011?
Make the answer very short. 1.53. What is the ratio of the Balance of Payment (as % of service imports) of Lithuania in 2008 to that in 2011?
Ensure brevity in your answer.  0.78. What is the ratio of the Balance of Payment (as % of service imports) of Malta in 2008 to that in 2011?
Make the answer very short. 0.89. What is the ratio of the Balance of Payment (as % of service imports) of Kosovo in 2008 to that in 2012?
Offer a very short reply. 1.3. What is the ratio of the Balance of Payment (as % of service imports) of Lithuania in 2008 to that in 2012?
Your answer should be compact. 0.8. What is the ratio of the Balance of Payment (as % of service imports) of Malta in 2008 to that in 2012?
Offer a terse response. 0.81. What is the ratio of the Balance of Payment (as % of service imports) of Kosovo in 2009 to that in 2010?
Your answer should be compact. 1.24. What is the ratio of the Balance of Payment (as % of service imports) of Lithuania in 2009 to that in 2010?
Offer a terse response. 0.76. What is the ratio of the Balance of Payment (as % of service imports) in Malta in 2009 to that in 2010?
Provide a succinct answer. 0.82. What is the ratio of the Balance of Payment (as % of service imports) of Kosovo in 2009 to that in 2011?
Give a very brief answer. 1.1. What is the ratio of the Balance of Payment (as % of service imports) in Lithuania in 2009 to that in 2011?
Your answer should be very brief. 0.67. What is the ratio of the Balance of Payment (as % of service imports) of Malta in 2009 to that in 2011?
Give a very brief answer. 0.75. What is the ratio of the Balance of Payment (as % of service imports) in Kosovo in 2009 to that in 2012?
Provide a short and direct response. 0.93. What is the ratio of the Balance of Payment (as % of service imports) of Lithuania in 2009 to that in 2012?
Make the answer very short. 0.69. What is the ratio of the Balance of Payment (as % of service imports) in Malta in 2009 to that in 2012?
Provide a short and direct response. 0.68. What is the ratio of the Balance of Payment (as % of service imports) of Kosovo in 2010 to that in 2011?
Ensure brevity in your answer.  0.89. What is the ratio of the Balance of Payment (as % of service imports) of Lithuania in 2010 to that in 2011?
Provide a succinct answer. 0.89. What is the ratio of the Balance of Payment (as % of service imports) in Malta in 2010 to that in 2011?
Offer a very short reply. 0.91. What is the ratio of the Balance of Payment (as % of service imports) in Kosovo in 2010 to that in 2012?
Keep it short and to the point. 0.75. What is the ratio of the Balance of Payment (as % of service imports) in Lithuania in 2010 to that in 2012?
Provide a short and direct response. 0.91. What is the ratio of the Balance of Payment (as % of service imports) of Malta in 2010 to that in 2012?
Ensure brevity in your answer.  0.83. What is the ratio of the Balance of Payment (as % of service imports) in Kosovo in 2011 to that in 2012?
Offer a terse response. 0.84. What is the ratio of the Balance of Payment (as % of service imports) of Lithuania in 2011 to that in 2012?
Give a very brief answer. 1.03. What is the ratio of the Balance of Payment (as % of service imports) in Malta in 2011 to that in 2012?
Make the answer very short. 0.91. What is the difference between the highest and the second highest Balance of Payment (as % of service imports) in Kosovo?
Provide a succinct answer. 5.1. What is the difference between the highest and the second highest Balance of Payment (as % of service imports) of Lithuania?
Offer a very short reply. 1.86. What is the difference between the highest and the second highest Balance of Payment (as % of service imports) in Malta?
Your response must be concise. 2.48. What is the difference between the highest and the lowest Balance of Payment (as % of service imports) of Kosovo?
Your answer should be compact. 13.82. What is the difference between the highest and the lowest Balance of Payment (as % of service imports) of Lithuania?
Ensure brevity in your answer.  18.96. What is the difference between the highest and the lowest Balance of Payment (as % of service imports) in Malta?
Offer a very short reply. 15.01. 